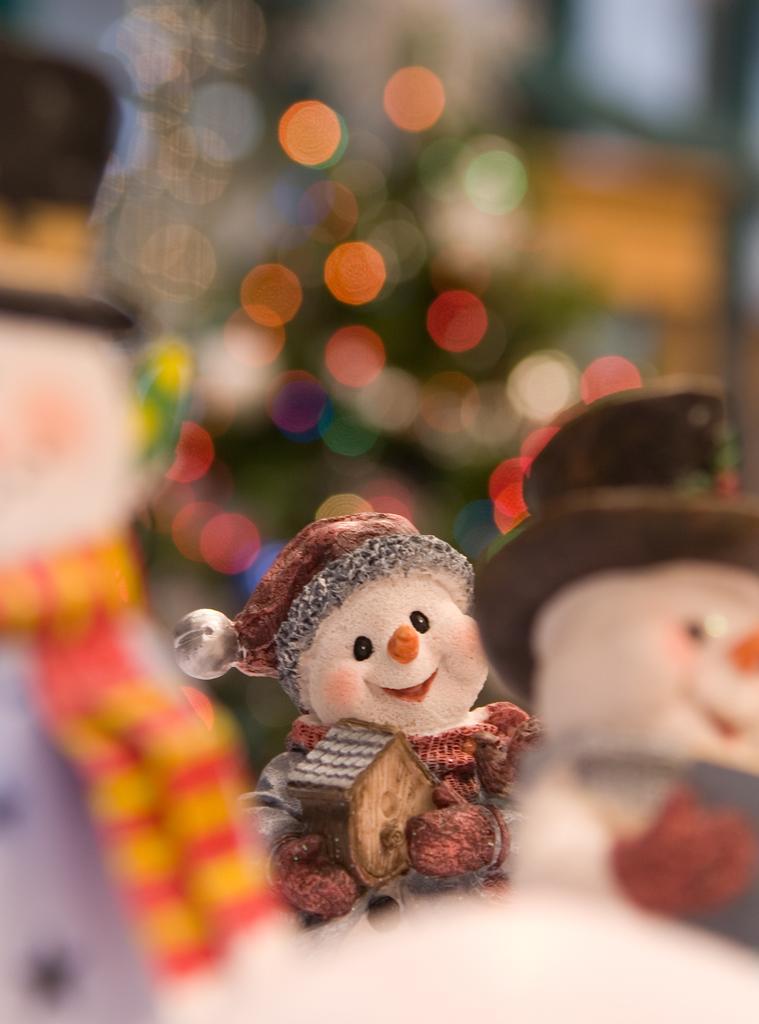In one or two sentences, can you explain what this image depicts? In this image we can see toys. In the background it is blur. 